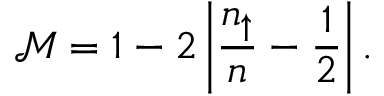Convert formula to latex. <formula><loc_0><loc_0><loc_500><loc_500>\mathcal { M } = 1 - 2 \left | \frac { n _ { \uparrow } } { n } - \frac { 1 } { 2 } \right | .</formula> 